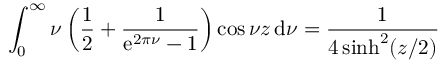Convert formula to latex. <formula><loc_0><loc_0><loc_500><loc_500>\int _ { 0 } ^ { \infty } \nu \left ( \frac { 1 } { 2 } + \frac { 1 } { e ^ { 2 \pi \nu } - 1 } \right ) \cos \nu z \, d \nu = \frac { 1 } { 4 \sinh ^ { 2 } ( z / 2 ) }</formula> 